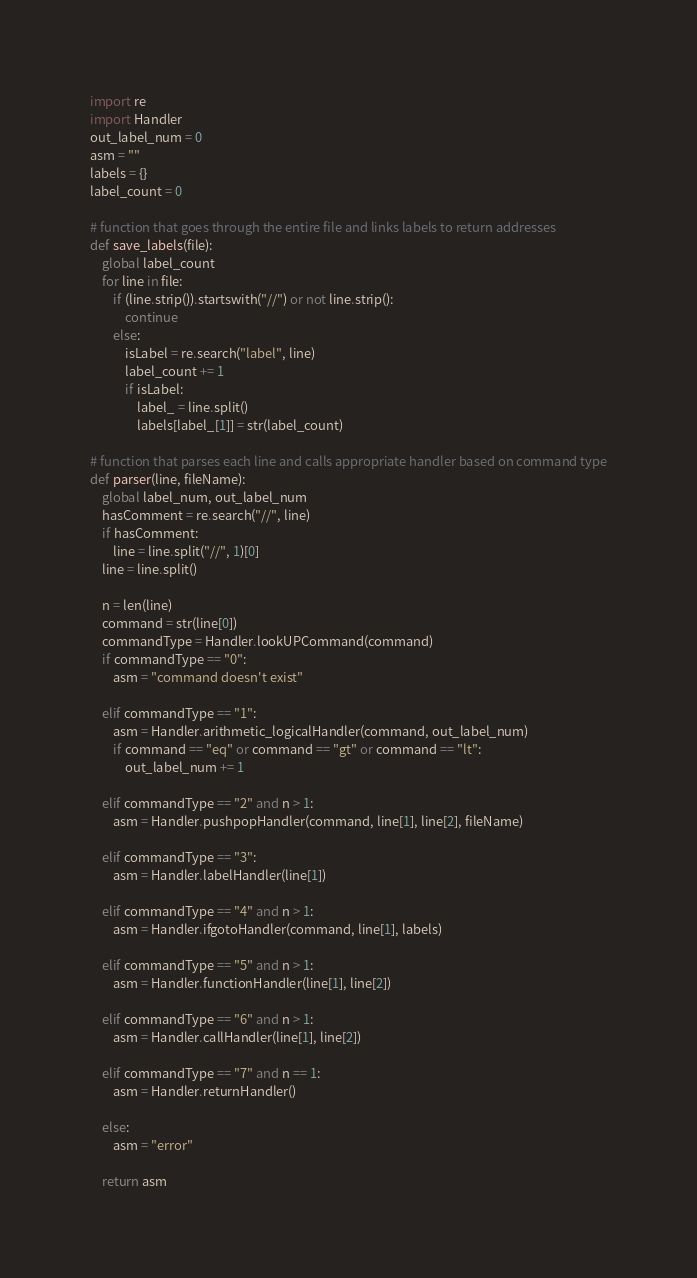Convert code to text. <code><loc_0><loc_0><loc_500><loc_500><_Python_>import re
import Handler
out_label_num = 0
asm = ""
labels = {}
label_count = 0

# function that goes through the entire file and links labels to return addresses
def save_labels(file):
    global label_count
    for line in file:
        if (line.strip()).startswith("//") or not line.strip():
            continue
        else:
            isLabel = re.search("label", line)
            label_count += 1
            if isLabel:
                label_ = line.split()
                labels[label_[1]] = str(label_count)

# function that parses each line and calls appropriate handler based on command type
def parser(line, fileName):
    global label_num, out_label_num
    hasComment = re.search("//", line)
    if hasComment:
        line = line.split("//", 1)[0]
    line = line.split()

    n = len(line)
    command = str(line[0])
    commandType = Handler.lookUPCommand(command)
    if commandType == "0":
        asm = "command doesn't exist"

    elif commandType == "1":
        asm = Handler.arithmetic_logicalHandler(command, out_label_num)
        if command == "eq" or command == "gt" or command == "lt":
            out_label_num += 1

    elif commandType == "2" and n > 1:
        asm = Handler.pushpopHandler(command, line[1], line[2], fileName)

    elif commandType == "3":
        asm = Handler.labelHandler(line[1])

    elif commandType == "4" and n > 1:
        asm = Handler.ifgotoHandler(command, line[1], labels)

    elif commandType == "5" and n > 1:
        asm = Handler.functionHandler(line[1], line[2])

    elif commandType == "6" and n > 1:
        asm = Handler.callHandler(line[1], line[2])

    elif commandType == "7" and n == 1:
        asm = Handler.returnHandler()

    else:
        asm = "error"

    return asm
</code> 